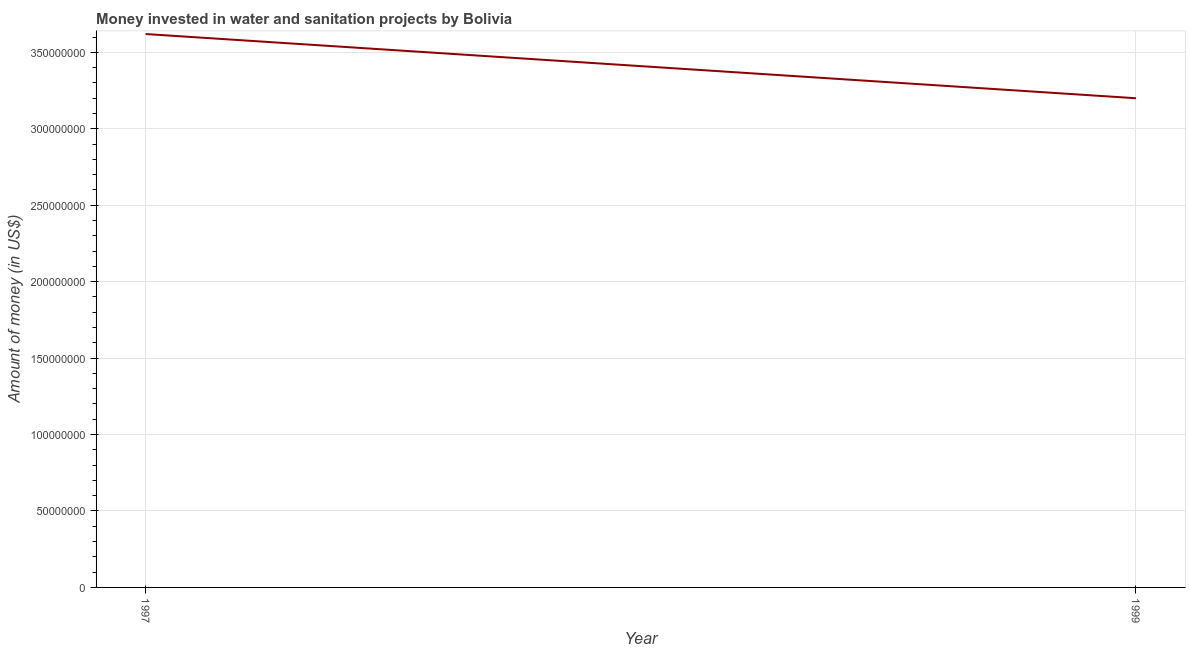What is the investment in 1999?
Give a very brief answer. 3.20e+08. Across all years, what is the maximum investment?
Give a very brief answer. 3.62e+08. Across all years, what is the minimum investment?
Offer a very short reply. 3.20e+08. What is the sum of the investment?
Provide a short and direct response. 6.82e+08. What is the difference between the investment in 1997 and 1999?
Keep it short and to the point. 4.20e+07. What is the average investment per year?
Your response must be concise. 3.41e+08. What is the median investment?
Your answer should be very brief. 3.41e+08. What is the ratio of the investment in 1997 to that in 1999?
Make the answer very short. 1.13. Is the investment in 1997 less than that in 1999?
Keep it short and to the point. No. In how many years, is the investment greater than the average investment taken over all years?
Provide a short and direct response. 1. Does the investment monotonically increase over the years?
Offer a terse response. No. How many lines are there?
Give a very brief answer. 1. How many years are there in the graph?
Offer a very short reply. 2. What is the difference between two consecutive major ticks on the Y-axis?
Provide a succinct answer. 5.00e+07. Are the values on the major ticks of Y-axis written in scientific E-notation?
Provide a short and direct response. No. Does the graph contain any zero values?
Make the answer very short. No. Does the graph contain grids?
Your response must be concise. Yes. What is the title of the graph?
Keep it short and to the point. Money invested in water and sanitation projects by Bolivia. What is the label or title of the X-axis?
Your response must be concise. Year. What is the label or title of the Y-axis?
Give a very brief answer. Amount of money (in US$). What is the Amount of money (in US$) in 1997?
Your answer should be very brief. 3.62e+08. What is the Amount of money (in US$) of 1999?
Offer a very short reply. 3.20e+08. What is the difference between the Amount of money (in US$) in 1997 and 1999?
Your response must be concise. 4.20e+07. What is the ratio of the Amount of money (in US$) in 1997 to that in 1999?
Make the answer very short. 1.13. 